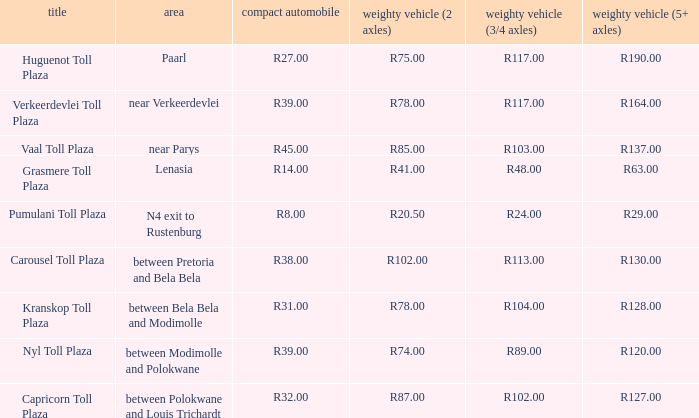What is the toll for light vehicles at the plaza between bela bela and modimolle? R31.00. 